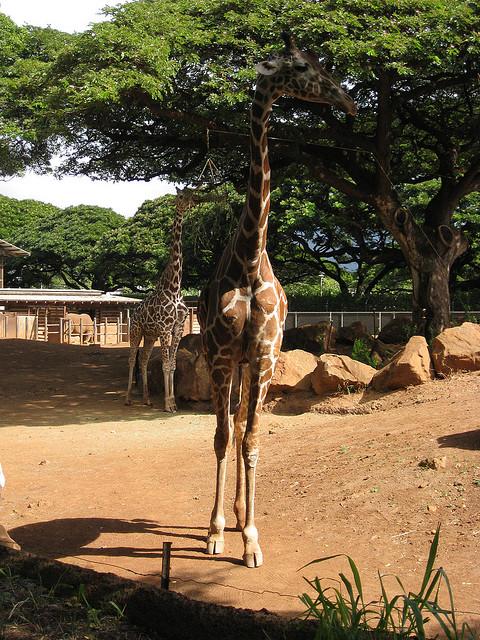Are there buildings in the background?
Give a very brief answer. Yes. Have you visited this zoo?
Quick response, please. No. Is it sunny?
Be succinct. Yes. How many animals are shown?
Write a very short answer. 2. 